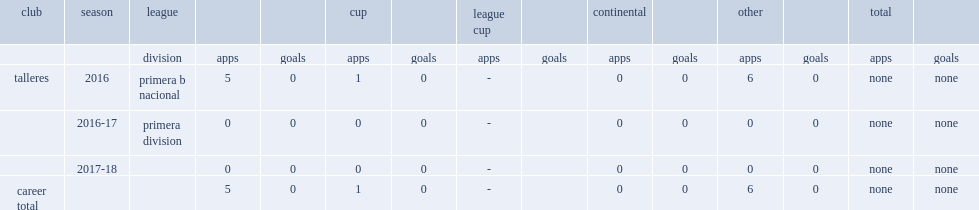Which club did fernando juarez play for in 2016? Talleres. 